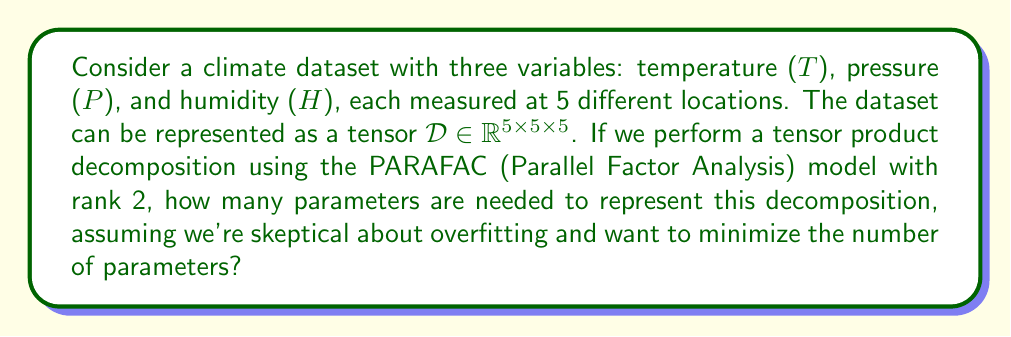Can you answer this question? Let's approach this step-by-step:

1) The PARAFAC decomposition of rank 2 for a 3-way tensor can be expressed as:

   $$\mathcal{D} \approx \sum_{r=1}^{2} \mathbf{a}_r \otimes \mathbf{b}_r \otimes \mathbf{c}_r$$

   where $\mathbf{a}_r, \mathbf{b}_r, \mathbf{c}_r$ are vectors corresponding to each mode.

2) In our case:
   - $\mathbf{a}_r$ represents temperature factors (5 elements)
   - $\mathbf{b}_r$ represents pressure factors (5 elements)
   - $\mathbf{c}_r$ represents humidity factors (5 elements)

3) For each rank (r = 1 and r = 2), we need:
   - 5 parameters for $\mathbf{a}_r$
   - 5 parameters for $\mathbf{b}_r$
   - 5 parameters for $\mathbf{c}_r$

4) Total parameters for one rank: 5 + 5 + 5 = 15

5) Since we have rank 2, we multiply by 2: 15 * 2 = 30

6) However, as climatologists skeptical about overfitting, we might want to impose constraints. A common constraint is to normalize two of the three factor vectors for each rank, leaving the scale in the third vector.

7) Normalization reduces the parameters by 1 for each normalized vector. So we subtract 2 parameters for each rank: 2 * 2 = 4

8) Final number of parameters: 30 - 4 = 26

This minimalistic approach aligns with the skepticism about predictive modeling, as it reduces the risk of overfitting while still capturing the main structure of the data.
Answer: 26 parameters 